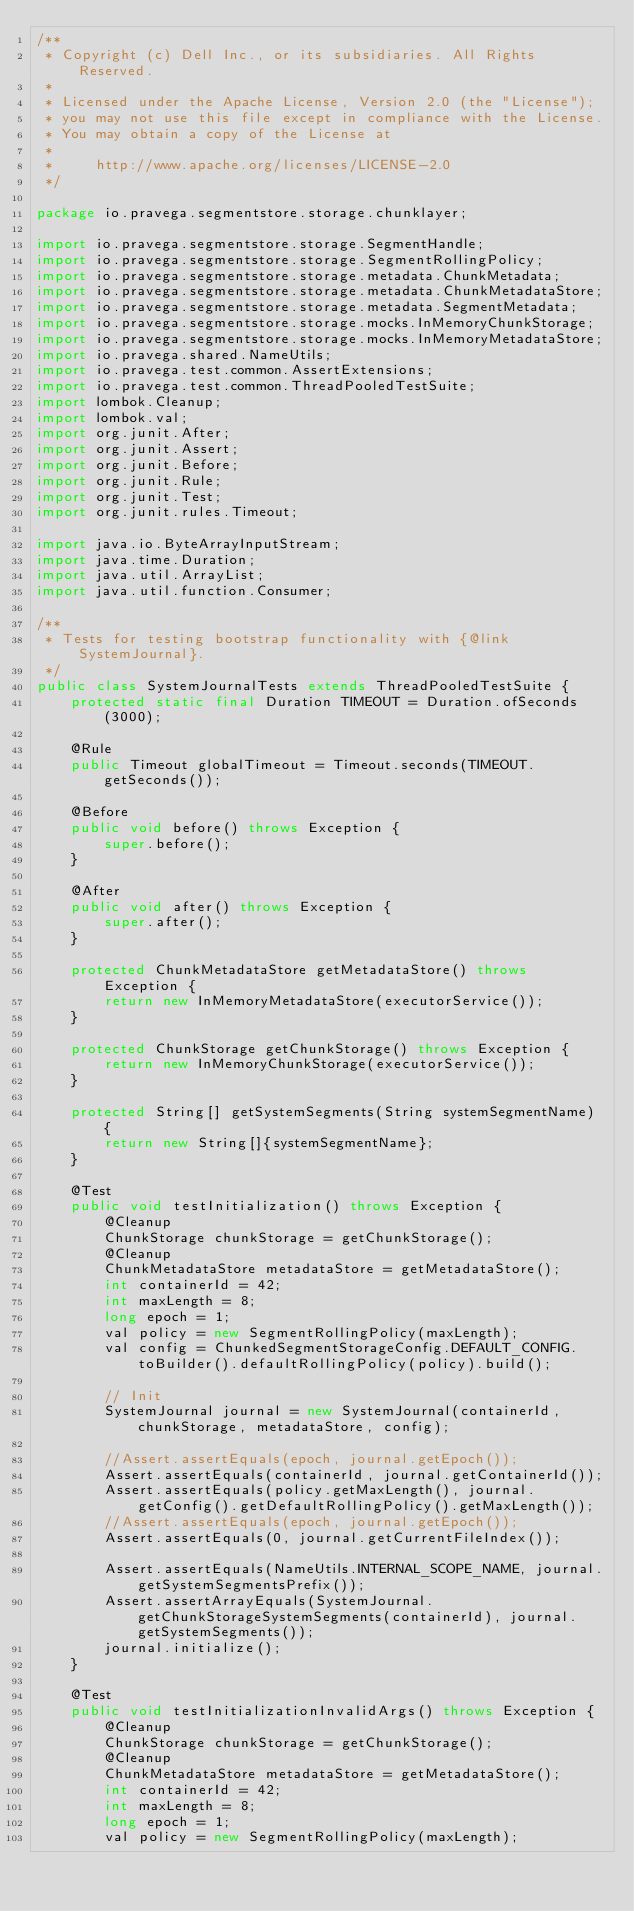Convert code to text. <code><loc_0><loc_0><loc_500><loc_500><_Java_>/**
 * Copyright (c) Dell Inc., or its subsidiaries. All Rights Reserved.
 *
 * Licensed under the Apache License, Version 2.0 (the "License");
 * you may not use this file except in compliance with the License.
 * You may obtain a copy of the License at
 *
 *     http://www.apache.org/licenses/LICENSE-2.0
 */

package io.pravega.segmentstore.storage.chunklayer;

import io.pravega.segmentstore.storage.SegmentHandle;
import io.pravega.segmentstore.storage.SegmentRollingPolicy;
import io.pravega.segmentstore.storage.metadata.ChunkMetadata;
import io.pravega.segmentstore.storage.metadata.ChunkMetadataStore;
import io.pravega.segmentstore.storage.metadata.SegmentMetadata;
import io.pravega.segmentstore.storage.mocks.InMemoryChunkStorage;
import io.pravega.segmentstore.storage.mocks.InMemoryMetadataStore;
import io.pravega.shared.NameUtils;
import io.pravega.test.common.AssertExtensions;
import io.pravega.test.common.ThreadPooledTestSuite;
import lombok.Cleanup;
import lombok.val;
import org.junit.After;
import org.junit.Assert;
import org.junit.Before;
import org.junit.Rule;
import org.junit.Test;
import org.junit.rules.Timeout;

import java.io.ByteArrayInputStream;
import java.time.Duration;
import java.util.ArrayList;
import java.util.function.Consumer;

/**
 * Tests for testing bootstrap functionality with {@link SystemJournal}.
 */
public class SystemJournalTests extends ThreadPooledTestSuite {
    protected static final Duration TIMEOUT = Duration.ofSeconds(3000);

    @Rule
    public Timeout globalTimeout = Timeout.seconds(TIMEOUT.getSeconds());

    @Before
    public void before() throws Exception {
        super.before();
    }

    @After
    public void after() throws Exception {
        super.after();
    }

    protected ChunkMetadataStore getMetadataStore() throws Exception {
        return new InMemoryMetadataStore(executorService());
    }

    protected ChunkStorage getChunkStorage() throws Exception {
        return new InMemoryChunkStorage(executorService());
    }

    protected String[] getSystemSegments(String systemSegmentName) {
        return new String[]{systemSegmentName};
    }

    @Test
    public void testInitialization() throws Exception {
        @Cleanup
        ChunkStorage chunkStorage = getChunkStorage();
        @Cleanup
        ChunkMetadataStore metadataStore = getMetadataStore();
        int containerId = 42;
        int maxLength = 8;
        long epoch = 1;
        val policy = new SegmentRollingPolicy(maxLength);
        val config = ChunkedSegmentStorageConfig.DEFAULT_CONFIG.toBuilder().defaultRollingPolicy(policy).build();

        // Init
        SystemJournal journal = new SystemJournal(containerId, chunkStorage, metadataStore, config);

        //Assert.assertEquals(epoch, journal.getEpoch());
        Assert.assertEquals(containerId, journal.getContainerId());
        Assert.assertEquals(policy.getMaxLength(), journal.getConfig().getDefaultRollingPolicy().getMaxLength());
        //Assert.assertEquals(epoch, journal.getEpoch());
        Assert.assertEquals(0, journal.getCurrentFileIndex());

        Assert.assertEquals(NameUtils.INTERNAL_SCOPE_NAME, journal.getSystemSegmentsPrefix());
        Assert.assertArrayEquals(SystemJournal.getChunkStorageSystemSegments(containerId), journal.getSystemSegments());
        journal.initialize();
    }

    @Test
    public void testInitializationInvalidArgs() throws Exception {
        @Cleanup
        ChunkStorage chunkStorage = getChunkStorage();
        @Cleanup
        ChunkMetadataStore metadataStore = getMetadataStore();
        int containerId = 42;
        int maxLength = 8;
        long epoch = 1;
        val policy = new SegmentRollingPolicy(maxLength);</code> 